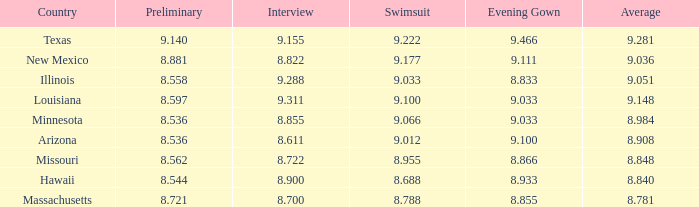848? 8.955. 